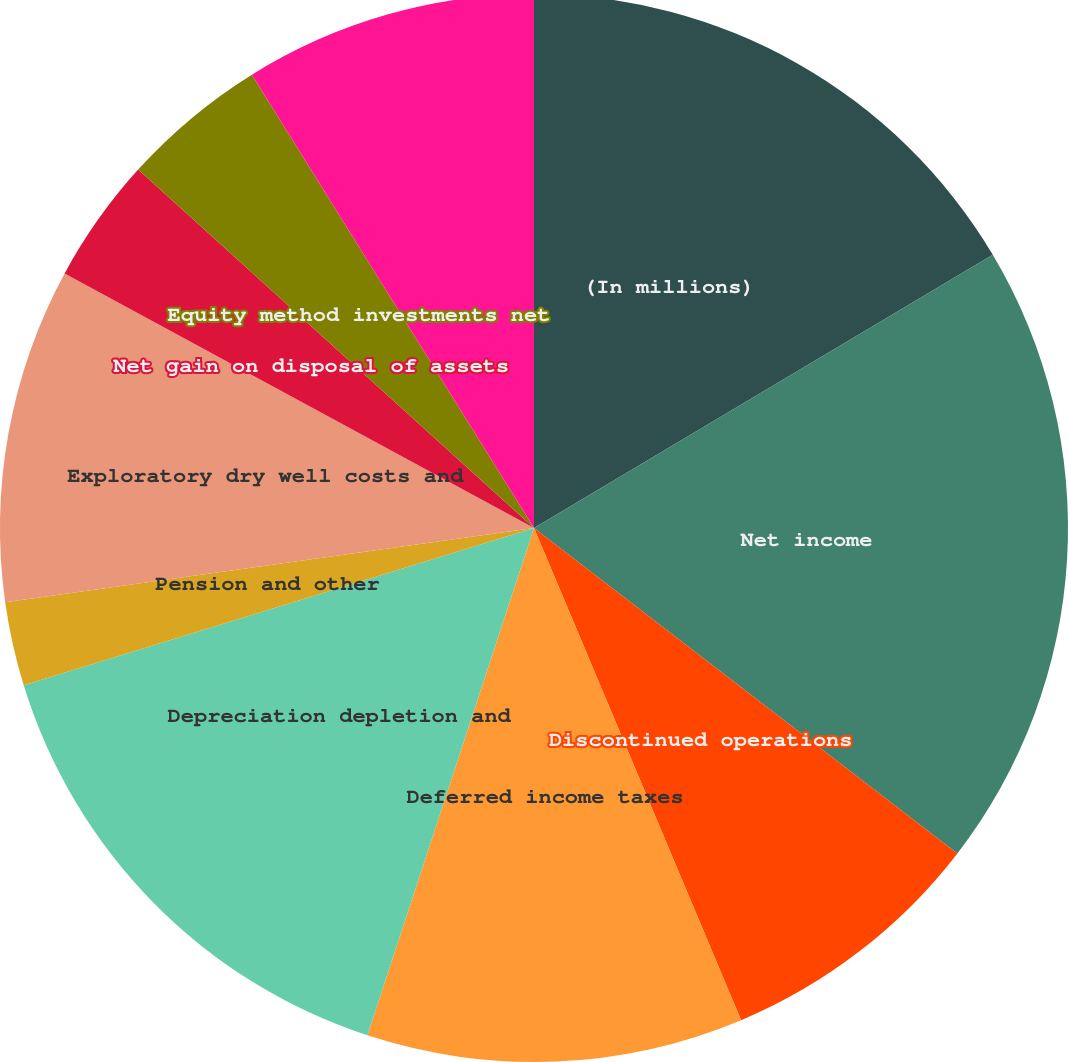Convert chart to OTSL. <chart><loc_0><loc_0><loc_500><loc_500><pie_chart><fcel>(In millions)<fcel>Net income<fcel>Discontinued operations<fcel>Deferred income taxes<fcel>Depreciation depletion and<fcel>Pension and other<fcel>Exploratory dry well costs and<fcel>Net gain on disposal of assets<fcel>Equity method investments net<fcel>Changes in the fair value of<nl><fcel>16.45%<fcel>18.98%<fcel>8.23%<fcel>11.39%<fcel>15.19%<fcel>2.54%<fcel>10.13%<fcel>3.8%<fcel>4.43%<fcel>8.86%<nl></chart> 